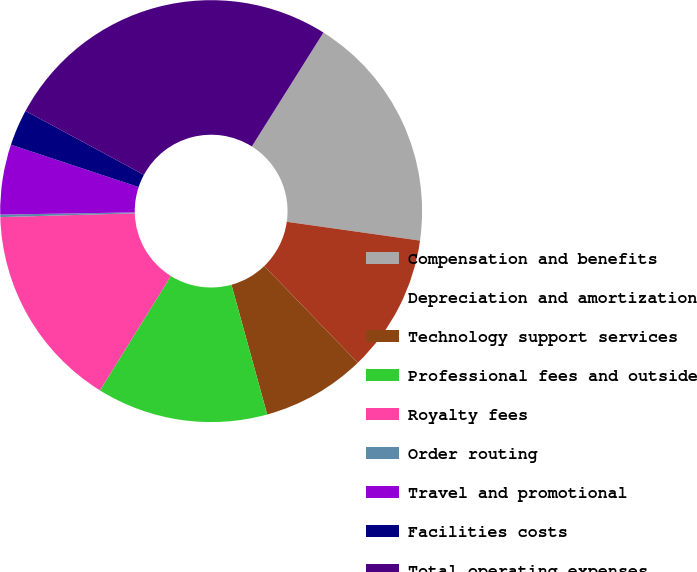Convert chart to OTSL. <chart><loc_0><loc_0><loc_500><loc_500><pie_chart><fcel>Compensation and benefits<fcel>Depreciation and amortization<fcel>Technology support services<fcel>Professional fees and outside<fcel>Royalty fees<fcel>Order routing<fcel>Travel and promotional<fcel>Facilities costs<fcel>Total operating expenses<nl><fcel>18.3%<fcel>10.54%<fcel>7.95%<fcel>13.12%<fcel>15.71%<fcel>0.19%<fcel>5.36%<fcel>2.78%<fcel>26.06%<nl></chart> 